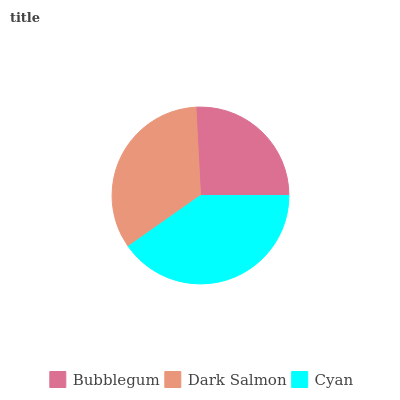Is Bubblegum the minimum?
Answer yes or no. Yes. Is Cyan the maximum?
Answer yes or no. Yes. Is Dark Salmon the minimum?
Answer yes or no. No. Is Dark Salmon the maximum?
Answer yes or no. No. Is Dark Salmon greater than Bubblegum?
Answer yes or no. Yes. Is Bubblegum less than Dark Salmon?
Answer yes or no. Yes. Is Bubblegum greater than Dark Salmon?
Answer yes or no. No. Is Dark Salmon less than Bubblegum?
Answer yes or no. No. Is Dark Salmon the high median?
Answer yes or no. Yes. Is Dark Salmon the low median?
Answer yes or no. Yes. Is Cyan the high median?
Answer yes or no. No. Is Cyan the low median?
Answer yes or no. No. 